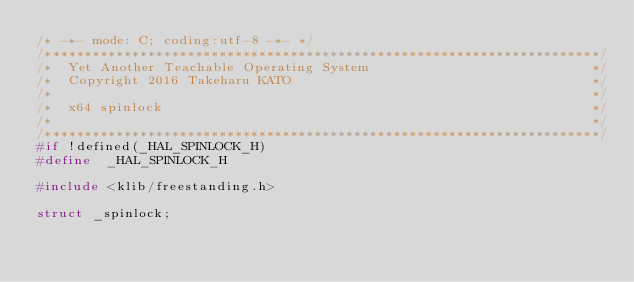<code> <loc_0><loc_0><loc_500><loc_500><_C_>/* -*- mode: C; coding:utf-8 -*- */
/**********************************************************************/
/*  Yet Another Teachable Operating System                            */
/*  Copyright 2016 Takeharu KATO                                      */
/*                                                                    */
/*  x64 spinlock                                                      */
/*                                                                    */
/**********************************************************************/
#if !defined(_HAL_SPINLOCK_H)
#define  _HAL_SPINLOCK_H 

#include <klib/freestanding.h>

struct _spinlock;
</code> 